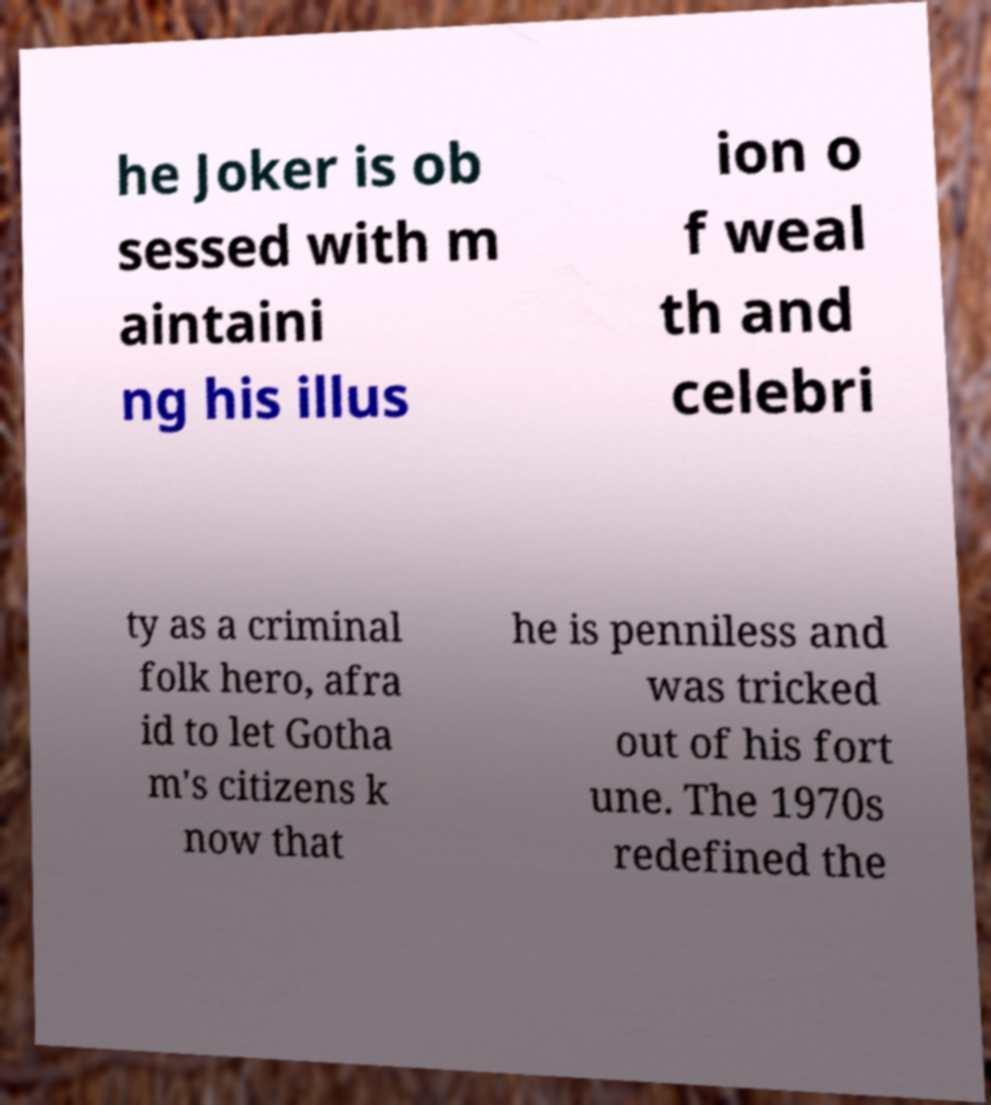There's text embedded in this image that I need extracted. Can you transcribe it verbatim? he Joker is ob sessed with m aintaini ng his illus ion o f weal th and celebri ty as a criminal folk hero, afra id to let Gotha m's citizens k now that he is penniless and was tricked out of his fort une. The 1970s redefined the 